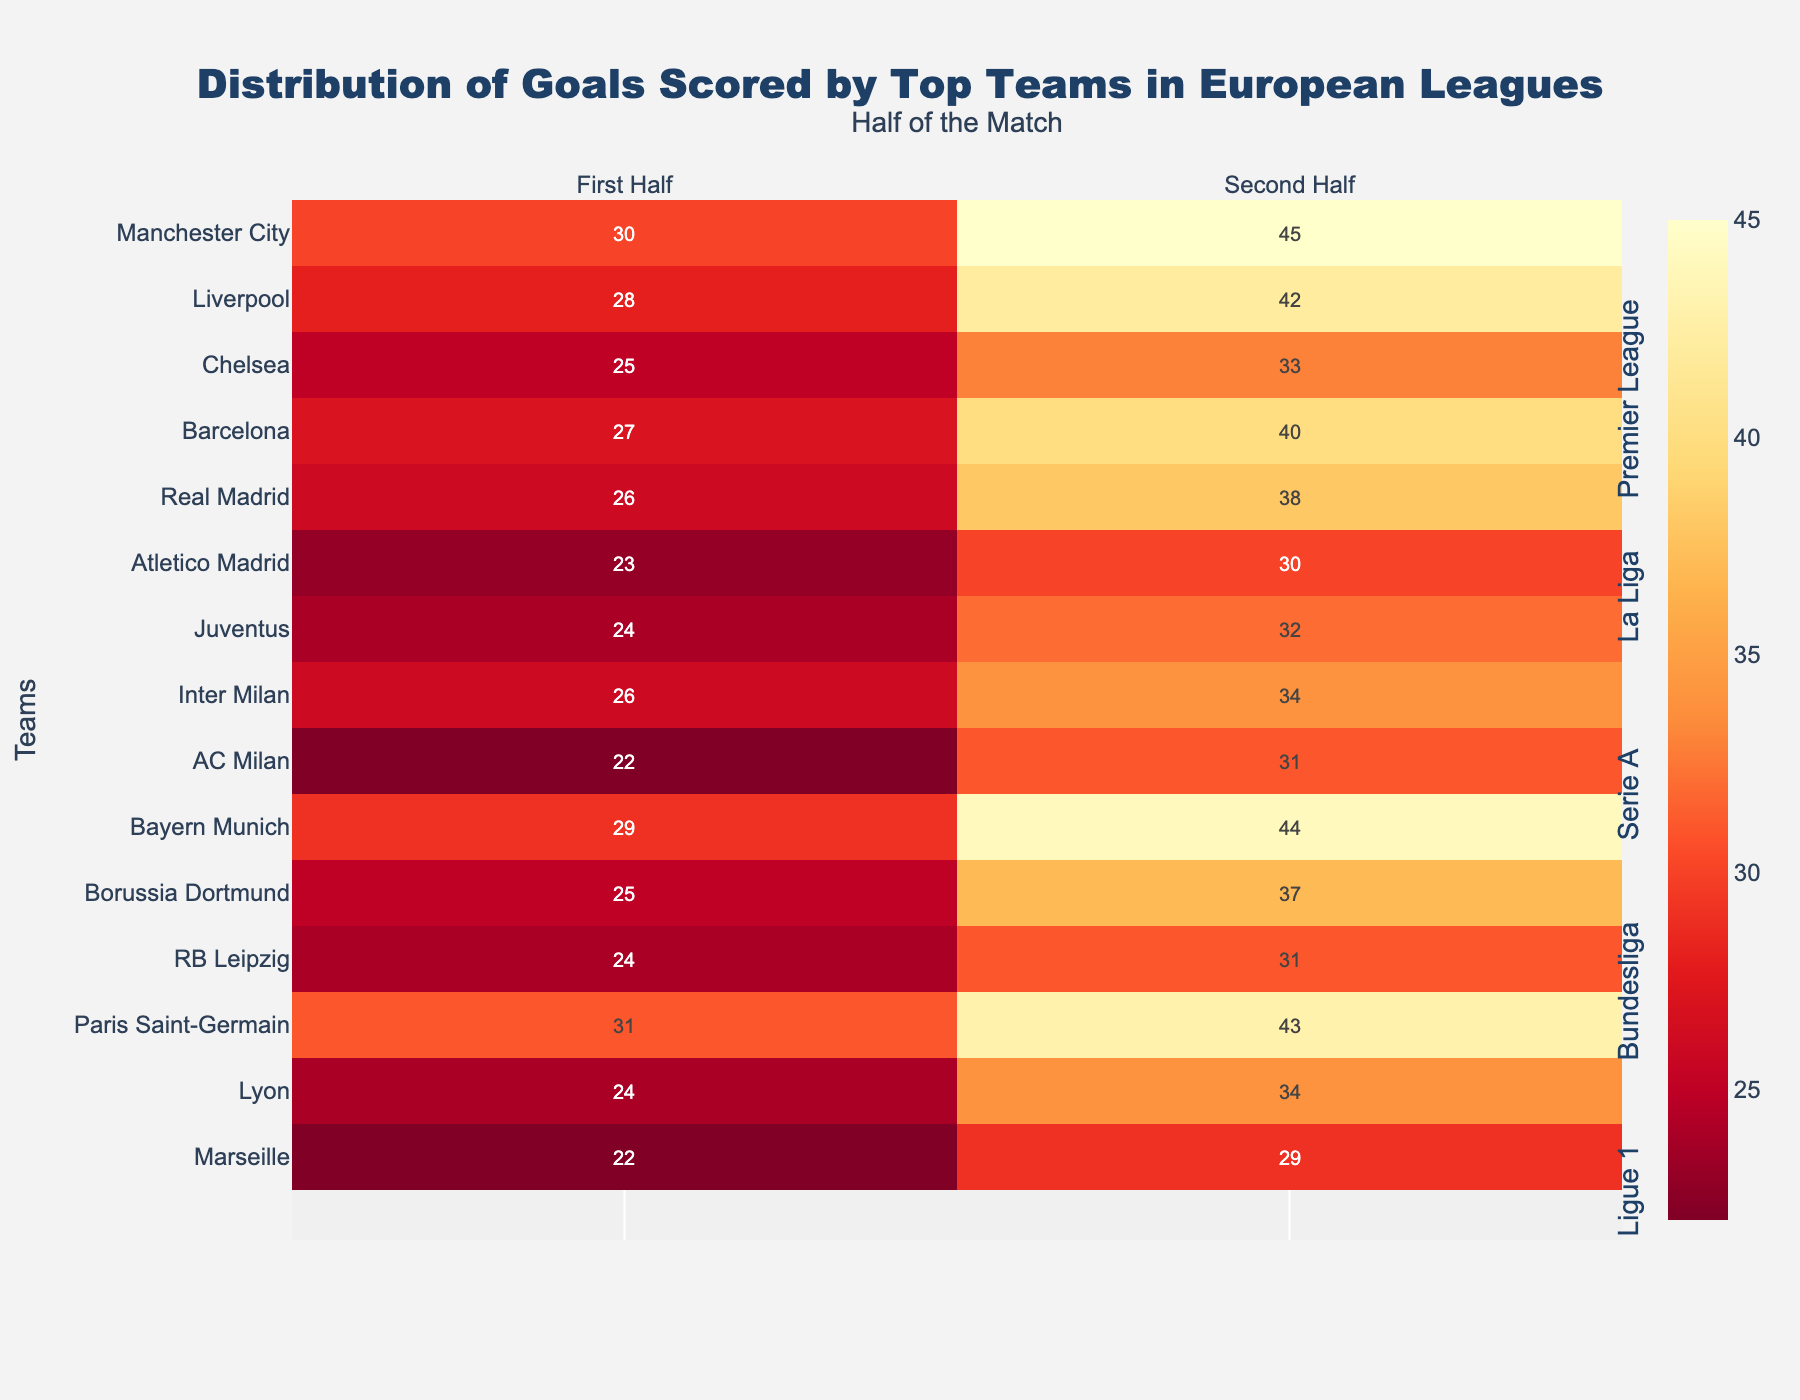Which team scored the most goals in the first half? By looking at the first half column, Manchester City scored the most goals in the first half with 30 goals.
Answer: Manchester City Which team has the highest total goals in the second half in Ligue 1? In the second half column for Ligue 1, Paris Saint-Germain scored the highest with 43 goals.
Answer: Paris Saint-Germain How many total goals did Real Madrid score? Total goals for Real Madrid, from the column 'Total_Goals', sum up to 64.
Answer: 64 What is the title of the figure? The title is displayed at the top of the figure which reads "Distribution of Goals Scored by Top Teams in European Leagues".
Answer: Distribution of Goals Scored by Top Teams in European Leagues Which team scored more goals in the second half than the first half in the Serie A league? Juventus, Inter Milan, and AC Milan scored more goals in the second half than the first half within Serie A teams.
Answer: Juventus; Inter Milan; AC Milan What is the combined total of first half goals for teams in the Premier League? Adding the first half goals for Manchester City (30), Liverpool (28), and Chelsea (25), total is 30 + 28 + 25 = 83.
Answer: 83 Are there more goals scored in the first half or the second half for teams overall? Comparing the columns, the teams scored more goals overall in the second half.
Answer: Second half Which team scored the highest number of second-half goals in Bundesliga? Identifying from the second half column in Bundesliga, Bayern Munich scored the highest with 44 goals.
Answer: Bayern Munich Which league had the team with the fewest total goals, and which team was it? Ligue 1 had the team with the fewest total goals, which is Marseille with 51 goals.
Answer: Ligue 1, Marseille 